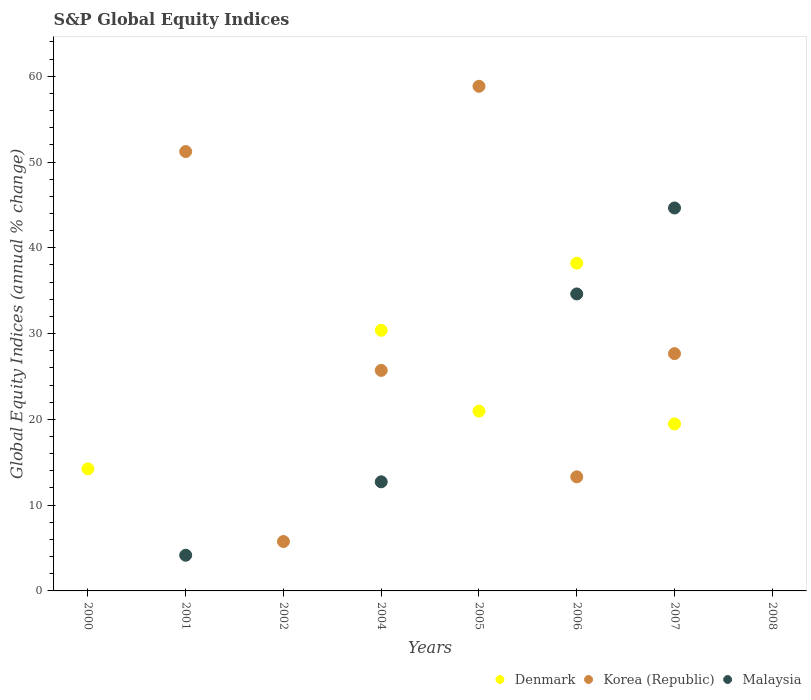How many different coloured dotlines are there?
Provide a short and direct response. 3. What is the global equity indices in Korea (Republic) in 2002?
Provide a succinct answer. 5.76. Across all years, what is the maximum global equity indices in Malaysia?
Provide a short and direct response. 44.64. Across all years, what is the minimum global equity indices in Malaysia?
Make the answer very short. 0. In which year was the global equity indices in Malaysia maximum?
Offer a terse response. 2007. What is the total global equity indices in Korea (Republic) in the graph?
Offer a terse response. 182.49. What is the difference between the global equity indices in Malaysia in 2001 and that in 2007?
Provide a succinct answer. -40.48. What is the difference between the global equity indices in Korea (Republic) in 2004 and the global equity indices in Denmark in 2000?
Offer a terse response. 11.48. What is the average global equity indices in Denmark per year?
Keep it short and to the point. 15.41. In the year 2004, what is the difference between the global equity indices in Korea (Republic) and global equity indices in Denmark?
Your response must be concise. -4.68. In how many years, is the global equity indices in Denmark greater than 62 %?
Ensure brevity in your answer.  0. What is the ratio of the global equity indices in Denmark in 2005 to that in 2006?
Give a very brief answer. 0.55. Is the difference between the global equity indices in Korea (Republic) in 2004 and 2006 greater than the difference between the global equity indices in Denmark in 2004 and 2006?
Provide a short and direct response. Yes. What is the difference between the highest and the second highest global equity indices in Denmark?
Provide a succinct answer. 7.82. What is the difference between the highest and the lowest global equity indices in Korea (Republic)?
Offer a terse response. 58.83. In how many years, is the global equity indices in Malaysia greater than the average global equity indices in Malaysia taken over all years?
Your response must be concise. 3. Is the sum of the global equity indices in Korea (Republic) in 2004 and 2007 greater than the maximum global equity indices in Denmark across all years?
Offer a very short reply. Yes. Is it the case that in every year, the sum of the global equity indices in Denmark and global equity indices in Korea (Republic)  is greater than the global equity indices in Malaysia?
Your answer should be compact. No. Does the global equity indices in Denmark monotonically increase over the years?
Your answer should be very brief. No. Is the global equity indices in Korea (Republic) strictly less than the global equity indices in Denmark over the years?
Your response must be concise. No. How many dotlines are there?
Provide a short and direct response. 3. How many years are there in the graph?
Keep it short and to the point. 8. Does the graph contain grids?
Keep it short and to the point. No. How many legend labels are there?
Your answer should be very brief. 3. What is the title of the graph?
Your response must be concise. S&P Global Equity Indices. What is the label or title of the X-axis?
Give a very brief answer. Years. What is the label or title of the Y-axis?
Provide a short and direct response. Global Equity Indices (annual % change). What is the Global Equity Indices (annual % change) of Denmark in 2000?
Provide a short and direct response. 14.23. What is the Global Equity Indices (annual % change) in Korea (Republic) in 2000?
Ensure brevity in your answer.  0. What is the Global Equity Indices (annual % change) in Malaysia in 2000?
Provide a short and direct response. 0. What is the Global Equity Indices (annual % change) in Denmark in 2001?
Keep it short and to the point. 0. What is the Global Equity Indices (annual % change) in Korea (Republic) in 2001?
Offer a very short reply. 51.22. What is the Global Equity Indices (annual % change) in Malaysia in 2001?
Your response must be concise. 4.16. What is the Global Equity Indices (annual % change) of Denmark in 2002?
Provide a short and direct response. 0. What is the Global Equity Indices (annual % change) of Korea (Republic) in 2002?
Offer a very short reply. 5.76. What is the Global Equity Indices (annual % change) of Malaysia in 2002?
Give a very brief answer. 0. What is the Global Equity Indices (annual % change) of Denmark in 2004?
Keep it short and to the point. 30.39. What is the Global Equity Indices (annual % change) in Korea (Republic) in 2004?
Offer a terse response. 25.71. What is the Global Equity Indices (annual % change) of Malaysia in 2004?
Ensure brevity in your answer.  12.72. What is the Global Equity Indices (annual % change) of Denmark in 2005?
Provide a short and direct response. 20.96. What is the Global Equity Indices (annual % change) in Korea (Republic) in 2005?
Ensure brevity in your answer.  58.83. What is the Global Equity Indices (annual % change) of Denmark in 2006?
Your response must be concise. 38.21. What is the Global Equity Indices (annual % change) of Korea (Republic) in 2006?
Your answer should be very brief. 13.3. What is the Global Equity Indices (annual % change) in Malaysia in 2006?
Your answer should be compact. 34.62. What is the Global Equity Indices (annual % change) of Denmark in 2007?
Keep it short and to the point. 19.47. What is the Global Equity Indices (annual % change) of Korea (Republic) in 2007?
Give a very brief answer. 27.66. What is the Global Equity Indices (annual % change) of Malaysia in 2007?
Your response must be concise. 44.64. What is the Global Equity Indices (annual % change) in Korea (Republic) in 2008?
Ensure brevity in your answer.  0. What is the Global Equity Indices (annual % change) in Malaysia in 2008?
Keep it short and to the point. 0. Across all years, what is the maximum Global Equity Indices (annual % change) in Denmark?
Your response must be concise. 38.21. Across all years, what is the maximum Global Equity Indices (annual % change) of Korea (Republic)?
Provide a succinct answer. 58.83. Across all years, what is the maximum Global Equity Indices (annual % change) in Malaysia?
Give a very brief answer. 44.64. Across all years, what is the minimum Global Equity Indices (annual % change) in Denmark?
Your response must be concise. 0. Across all years, what is the minimum Global Equity Indices (annual % change) in Malaysia?
Ensure brevity in your answer.  0. What is the total Global Equity Indices (annual % change) of Denmark in the graph?
Your answer should be compact. 123.26. What is the total Global Equity Indices (annual % change) in Korea (Republic) in the graph?
Provide a succinct answer. 182.49. What is the total Global Equity Indices (annual % change) of Malaysia in the graph?
Your answer should be very brief. 96.15. What is the difference between the Global Equity Indices (annual % change) of Denmark in 2000 and that in 2004?
Offer a very short reply. -16.16. What is the difference between the Global Equity Indices (annual % change) of Denmark in 2000 and that in 2005?
Ensure brevity in your answer.  -6.73. What is the difference between the Global Equity Indices (annual % change) of Denmark in 2000 and that in 2006?
Offer a very short reply. -23.97. What is the difference between the Global Equity Indices (annual % change) of Denmark in 2000 and that in 2007?
Your answer should be very brief. -5.23. What is the difference between the Global Equity Indices (annual % change) of Korea (Republic) in 2001 and that in 2002?
Offer a very short reply. 45.46. What is the difference between the Global Equity Indices (annual % change) of Korea (Republic) in 2001 and that in 2004?
Give a very brief answer. 25.51. What is the difference between the Global Equity Indices (annual % change) in Malaysia in 2001 and that in 2004?
Keep it short and to the point. -8.56. What is the difference between the Global Equity Indices (annual % change) of Korea (Republic) in 2001 and that in 2005?
Provide a succinct answer. -7.61. What is the difference between the Global Equity Indices (annual % change) of Korea (Republic) in 2001 and that in 2006?
Offer a terse response. 37.92. What is the difference between the Global Equity Indices (annual % change) of Malaysia in 2001 and that in 2006?
Provide a short and direct response. -30.46. What is the difference between the Global Equity Indices (annual % change) in Korea (Republic) in 2001 and that in 2007?
Your answer should be very brief. 23.56. What is the difference between the Global Equity Indices (annual % change) of Malaysia in 2001 and that in 2007?
Keep it short and to the point. -40.48. What is the difference between the Global Equity Indices (annual % change) in Korea (Republic) in 2002 and that in 2004?
Ensure brevity in your answer.  -19.95. What is the difference between the Global Equity Indices (annual % change) of Korea (Republic) in 2002 and that in 2005?
Your response must be concise. -53.07. What is the difference between the Global Equity Indices (annual % change) of Korea (Republic) in 2002 and that in 2006?
Your answer should be compact. -7.54. What is the difference between the Global Equity Indices (annual % change) of Korea (Republic) in 2002 and that in 2007?
Keep it short and to the point. -21.9. What is the difference between the Global Equity Indices (annual % change) of Denmark in 2004 and that in 2005?
Your answer should be very brief. 9.43. What is the difference between the Global Equity Indices (annual % change) in Korea (Republic) in 2004 and that in 2005?
Your answer should be very brief. -33.12. What is the difference between the Global Equity Indices (annual % change) in Denmark in 2004 and that in 2006?
Offer a very short reply. -7.82. What is the difference between the Global Equity Indices (annual % change) of Korea (Republic) in 2004 and that in 2006?
Offer a very short reply. 12.41. What is the difference between the Global Equity Indices (annual % change) of Malaysia in 2004 and that in 2006?
Provide a short and direct response. -21.9. What is the difference between the Global Equity Indices (annual % change) of Denmark in 2004 and that in 2007?
Give a very brief answer. 10.92. What is the difference between the Global Equity Indices (annual % change) of Korea (Republic) in 2004 and that in 2007?
Your answer should be very brief. -1.95. What is the difference between the Global Equity Indices (annual % change) in Malaysia in 2004 and that in 2007?
Your response must be concise. -31.92. What is the difference between the Global Equity Indices (annual % change) in Denmark in 2005 and that in 2006?
Offer a very short reply. -17.25. What is the difference between the Global Equity Indices (annual % change) of Korea (Republic) in 2005 and that in 2006?
Your answer should be very brief. 45.53. What is the difference between the Global Equity Indices (annual % change) of Denmark in 2005 and that in 2007?
Offer a terse response. 1.5. What is the difference between the Global Equity Indices (annual % change) in Korea (Republic) in 2005 and that in 2007?
Ensure brevity in your answer.  31.17. What is the difference between the Global Equity Indices (annual % change) in Denmark in 2006 and that in 2007?
Your answer should be compact. 18.74. What is the difference between the Global Equity Indices (annual % change) in Korea (Republic) in 2006 and that in 2007?
Make the answer very short. -14.36. What is the difference between the Global Equity Indices (annual % change) of Malaysia in 2006 and that in 2007?
Your answer should be compact. -10.02. What is the difference between the Global Equity Indices (annual % change) of Denmark in 2000 and the Global Equity Indices (annual % change) of Korea (Republic) in 2001?
Make the answer very short. -36.99. What is the difference between the Global Equity Indices (annual % change) of Denmark in 2000 and the Global Equity Indices (annual % change) of Malaysia in 2001?
Ensure brevity in your answer.  10.07. What is the difference between the Global Equity Indices (annual % change) of Denmark in 2000 and the Global Equity Indices (annual % change) of Korea (Republic) in 2002?
Offer a terse response. 8.47. What is the difference between the Global Equity Indices (annual % change) of Denmark in 2000 and the Global Equity Indices (annual % change) of Korea (Republic) in 2004?
Your response must be concise. -11.48. What is the difference between the Global Equity Indices (annual % change) in Denmark in 2000 and the Global Equity Indices (annual % change) in Malaysia in 2004?
Offer a very short reply. 1.51. What is the difference between the Global Equity Indices (annual % change) of Denmark in 2000 and the Global Equity Indices (annual % change) of Korea (Republic) in 2005?
Provide a succinct answer. -44.6. What is the difference between the Global Equity Indices (annual % change) in Denmark in 2000 and the Global Equity Indices (annual % change) in Korea (Republic) in 2006?
Offer a very short reply. 0.93. What is the difference between the Global Equity Indices (annual % change) of Denmark in 2000 and the Global Equity Indices (annual % change) of Malaysia in 2006?
Your answer should be very brief. -20.39. What is the difference between the Global Equity Indices (annual % change) in Denmark in 2000 and the Global Equity Indices (annual % change) in Korea (Republic) in 2007?
Your answer should be compact. -13.43. What is the difference between the Global Equity Indices (annual % change) in Denmark in 2000 and the Global Equity Indices (annual % change) in Malaysia in 2007?
Offer a very short reply. -30.41. What is the difference between the Global Equity Indices (annual % change) of Korea (Republic) in 2001 and the Global Equity Indices (annual % change) of Malaysia in 2004?
Provide a succinct answer. 38.5. What is the difference between the Global Equity Indices (annual % change) of Korea (Republic) in 2001 and the Global Equity Indices (annual % change) of Malaysia in 2006?
Your response must be concise. 16.6. What is the difference between the Global Equity Indices (annual % change) in Korea (Republic) in 2001 and the Global Equity Indices (annual % change) in Malaysia in 2007?
Provide a short and direct response. 6.58. What is the difference between the Global Equity Indices (annual % change) of Korea (Republic) in 2002 and the Global Equity Indices (annual % change) of Malaysia in 2004?
Your answer should be compact. -6.96. What is the difference between the Global Equity Indices (annual % change) of Korea (Republic) in 2002 and the Global Equity Indices (annual % change) of Malaysia in 2006?
Your response must be concise. -28.86. What is the difference between the Global Equity Indices (annual % change) in Korea (Republic) in 2002 and the Global Equity Indices (annual % change) in Malaysia in 2007?
Provide a short and direct response. -38.88. What is the difference between the Global Equity Indices (annual % change) of Denmark in 2004 and the Global Equity Indices (annual % change) of Korea (Republic) in 2005?
Ensure brevity in your answer.  -28.44. What is the difference between the Global Equity Indices (annual % change) in Denmark in 2004 and the Global Equity Indices (annual % change) in Korea (Republic) in 2006?
Provide a short and direct response. 17.09. What is the difference between the Global Equity Indices (annual % change) of Denmark in 2004 and the Global Equity Indices (annual % change) of Malaysia in 2006?
Give a very brief answer. -4.23. What is the difference between the Global Equity Indices (annual % change) in Korea (Republic) in 2004 and the Global Equity Indices (annual % change) in Malaysia in 2006?
Your response must be concise. -8.91. What is the difference between the Global Equity Indices (annual % change) in Denmark in 2004 and the Global Equity Indices (annual % change) in Korea (Republic) in 2007?
Provide a short and direct response. 2.73. What is the difference between the Global Equity Indices (annual % change) of Denmark in 2004 and the Global Equity Indices (annual % change) of Malaysia in 2007?
Provide a short and direct response. -14.26. What is the difference between the Global Equity Indices (annual % change) of Korea (Republic) in 2004 and the Global Equity Indices (annual % change) of Malaysia in 2007?
Offer a very short reply. -18.93. What is the difference between the Global Equity Indices (annual % change) of Denmark in 2005 and the Global Equity Indices (annual % change) of Korea (Republic) in 2006?
Provide a short and direct response. 7.66. What is the difference between the Global Equity Indices (annual % change) in Denmark in 2005 and the Global Equity Indices (annual % change) in Malaysia in 2006?
Your answer should be very brief. -13.66. What is the difference between the Global Equity Indices (annual % change) of Korea (Republic) in 2005 and the Global Equity Indices (annual % change) of Malaysia in 2006?
Provide a succinct answer. 24.21. What is the difference between the Global Equity Indices (annual % change) in Denmark in 2005 and the Global Equity Indices (annual % change) in Korea (Republic) in 2007?
Your answer should be compact. -6.7. What is the difference between the Global Equity Indices (annual % change) in Denmark in 2005 and the Global Equity Indices (annual % change) in Malaysia in 2007?
Ensure brevity in your answer.  -23.68. What is the difference between the Global Equity Indices (annual % change) of Korea (Republic) in 2005 and the Global Equity Indices (annual % change) of Malaysia in 2007?
Provide a short and direct response. 14.19. What is the difference between the Global Equity Indices (annual % change) in Denmark in 2006 and the Global Equity Indices (annual % change) in Korea (Republic) in 2007?
Offer a terse response. 10.55. What is the difference between the Global Equity Indices (annual % change) in Denmark in 2006 and the Global Equity Indices (annual % change) in Malaysia in 2007?
Provide a short and direct response. -6.44. What is the difference between the Global Equity Indices (annual % change) of Korea (Republic) in 2006 and the Global Equity Indices (annual % change) of Malaysia in 2007?
Ensure brevity in your answer.  -31.34. What is the average Global Equity Indices (annual % change) of Denmark per year?
Provide a succinct answer. 15.41. What is the average Global Equity Indices (annual % change) in Korea (Republic) per year?
Offer a terse response. 22.81. What is the average Global Equity Indices (annual % change) of Malaysia per year?
Make the answer very short. 12.02. In the year 2001, what is the difference between the Global Equity Indices (annual % change) of Korea (Republic) and Global Equity Indices (annual % change) of Malaysia?
Your answer should be compact. 47.06. In the year 2004, what is the difference between the Global Equity Indices (annual % change) in Denmark and Global Equity Indices (annual % change) in Korea (Republic)?
Offer a very short reply. 4.68. In the year 2004, what is the difference between the Global Equity Indices (annual % change) of Denmark and Global Equity Indices (annual % change) of Malaysia?
Provide a succinct answer. 17.67. In the year 2004, what is the difference between the Global Equity Indices (annual % change) of Korea (Republic) and Global Equity Indices (annual % change) of Malaysia?
Your response must be concise. 12.99. In the year 2005, what is the difference between the Global Equity Indices (annual % change) of Denmark and Global Equity Indices (annual % change) of Korea (Republic)?
Make the answer very short. -37.87. In the year 2006, what is the difference between the Global Equity Indices (annual % change) in Denmark and Global Equity Indices (annual % change) in Korea (Republic)?
Give a very brief answer. 24.91. In the year 2006, what is the difference between the Global Equity Indices (annual % change) of Denmark and Global Equity Indices (annual % change) of Malaysia?
Provide a short and direct response. 3.59. In the year 2006, what is the difference between the Global Equity Indices (annual % change) of Korea (Republic) and Global Equity Indices (annual % change) of Malaysia?
Keep it short and to the point. -21.32. In the year 2007, what is the difference between the Global Equity Indices (annual % change) of Denmark and Global Equity Indices (annual % change) of Korea (Republic)?
Provide a succinct answer. -8.2. In the year 2007, what is the difference between the Global Equity Indices (annual % change) in Denmark and Global Equity Indices (annual % change) in Malaysia?
Your response must be concise. -25.18. In the year 2007, what is the difference between the Global Equity Indices (annual % change) of Korea (Republic) and Global Equity Indices (annual % change) of Malaysia?
Offer a very short reply. -16.98. What is the ratio of the Global Equity Indices (annual % change) in Denmark in 2000 to that in 2004?
Offer a very short reply. 0.47. What is the ratio of the Global Equity Indices (annual % change) in Denmark in 2000 to that in 2005?
Your response must be concise. 0.68. What is the ratio of the Global Equity Indices (annual % change) of Denmark in 2000 to that in 2006?
Offer a terse response. 0.37. What is the ratio of the Global Equity Indices (annual % change) of Denmark in 2000 to that in 2007?
Offer a terse response. 0.73. What is the ratio of the Global Equity Indices (annual % change) in Korea (Republic) in 2001 to that in 2002?
Make the answer very short. 8.89. What is the ratio of the Global Equity Indices (annual % change) in Korea (Republic) in 2001 to that in 2004?
Provide a succinct answer. 1.99. What is the ratio of the Global Equity Indices (annual % change) in Malaysia in 2001 to that in 2004?
Offer a very short reply. 0.33. What is the ratio of the Global Equity Indices (annual % change) of Korea (Republic) in 2001 to that in 2005?
Ensure brevity in your answer.  0.87. What is the ratio of the Global Equity Indices (annual % change) of Korea (Republic) in 2001 to that in 2006?
Provide a succinct answer. 3.85. What is the ratio of the Global Equity Indices (annual % change) of Malaysia in 2001 to that in 2006?
Your answer should be compact. 0.12. What is the ratio of the Global Equity Indices (annual % change) in Korea (Republic) in 2001 to that in 2007?
Keep it short and to the point. 1.85. What is the ratio of the Global Equity Indices (annual % change) of Malaysia in 2001 to that in 2007?
Make the answer very short. 0.09. What is the ratio of the Global Equity Indices (annual % change) of Korea (Republic) in 2002 to that in 2004?
Your response must be concise. 0.22. What is the ratio of the Global Equity Indices (annual % change) in Korea (Republic) in 2002 to that in 2005?
Provide a short and direct response. 0.1. What is the ratio of the Global Equity Indices (annual % change) in Korea (Republic) in 2002 to that in 2006?
Offer a terse response. 0.43. What is the ratio of the Global Equity Indices (annual % change) in Korea (Republic) in 2002 to that in 2007?
Provide a succinct answer. 0.21. What is the ratio of the Global Equity Indices (annual % change) of Denmark in 2004 to that in 2005?
Keep it short and to the point. 1.45. What is the ratio of the Global Equity Indices (annual % change) in Korea (Republic) in 2004 to that in 2005?
Give a very brief answer. 0.44. What is the ratio of the Global Equity Indices (annual % change) in Denmark in 2004 to that in 2006?
Your response must be concise. 0.8. What is the ratio of the Global Equity Indices (annual % change) of Korea (Republic) in 2004 to that in 2006?
Your answer should be very brief. 1.93. What is the ratio of the Global Equity Indices (annual % change) of Malaysia in 2004 to that in 2006?
Your response must be concise. 0.37. What is the ratio of the Global Equity Indices (annual % change) of Denmark in 2004 to that in 2007?
Ensure brevity in your answer.  1.56. What is the ratio of the Global Equity Indices (annual % change) of Korea (Republic) in 2004 to that in 2007?
Provide a succinct answer. 0.93. What is the ratio of the Global Equity Indices (annual % change) of Malaysia in 2004 to that in 2007?
Provide a short and direct response. 0.28. What is the ratio of the Global Equity Indices (annual % change) of Denmark in 2005 to that in 2006?
Give a very brief answer. 0.55. What is the ratio of the Global Equity Indices (annual % change) of Korea (Republic) in 2005 to that in 2006?
Provide a succinct answer. 4.42. What is the ratio of the Global Equity Indices (annual % change) in Korea (Republic) in 2005 to that in 2007?
Make the answer very short. 2.13. What is the ratio of the Global Equity Indices (annual % change) in Denmark in 2006 to that in 2007?
Give a very brief answer. 1.96. What is the ratio of the Global Equity Indices (annual % change) of Korea (Republic) in 2006 to that in 2007?
Your response must be concise. 0.48. What is the ratio of the Global Equity Indices (annual % change) in Malaysia in 2006 to that in 2007?
Your answer should be compact. 0.78. What is the difference between the highest and the second highest Global Equity Indices (annual % change) in Denmark?
Provide a succinct answer. 7.82. What is the difference between the highest and the second highest Global Equity Indices (annual % change) in Korea (Republic)?
Offer a very short reply. 7.61. What is the difference between the highest and the second highest Global Equity Indices (annual % change) of Malaysia?
Offer a very short reply. 10.02. What is the difference between the highest and the lowest Global Equity Indices (annual % change) of Denmark?
Your answer should be very brief. 38.21. What is the difference between the highest and the lowest Global Equity Indices (annual % change) in Korea (Republic)?
Your response must be concise. 58.83. What is the difference between the highest and the lowest Global Equity Indices (annual % change) of Malaysia?
Make the answer very short. 44.64. 